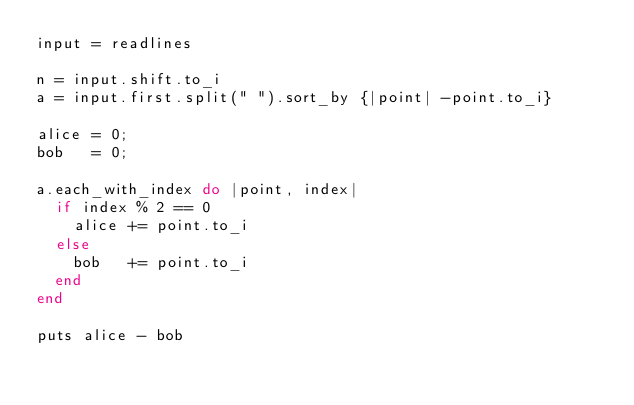Convert code to text. <code><loc_0><loc_0><loc_500><loc_500><_Ruby_>input = readlines

n = input.shift.to_i
a = input.first.split(" ").sort_by {|point| -point.to_i}

alice = 0;
bob   = 0;

a.each_with_index do |point, index|
  if index % 2 == 0
    alice += point.to_i
  else
    bob   += point.to_i
  end
end

puts alice - bob</code> 